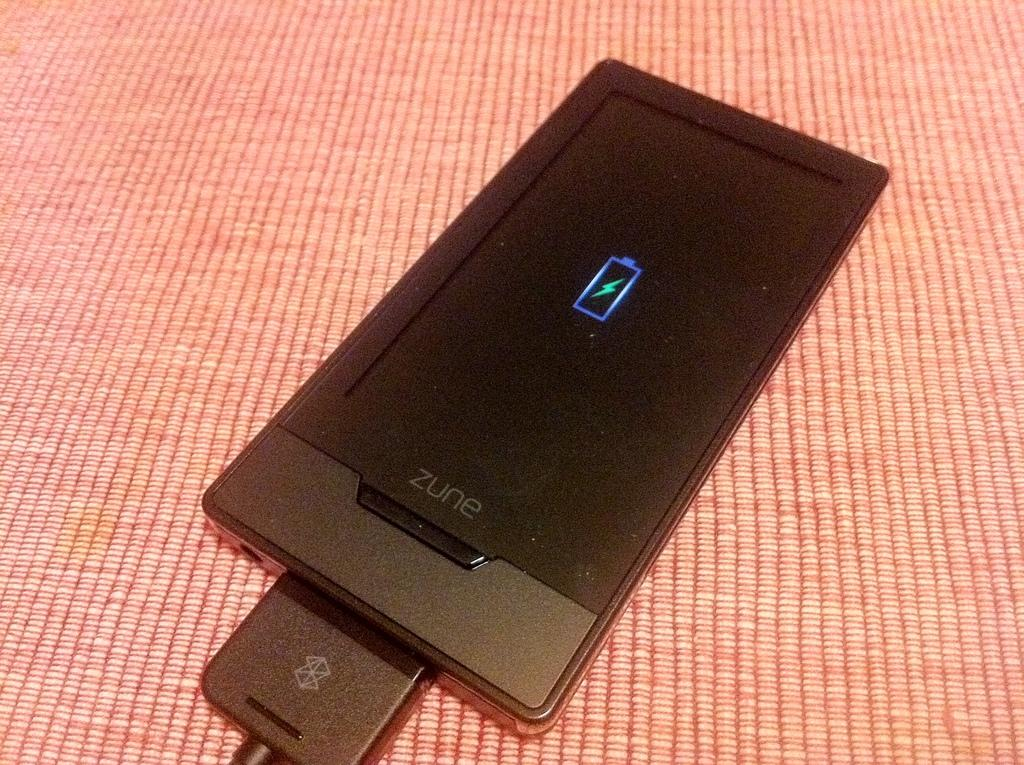<image>
Share a concise interpretation of the image provided. A black Zune is off and is charging. 